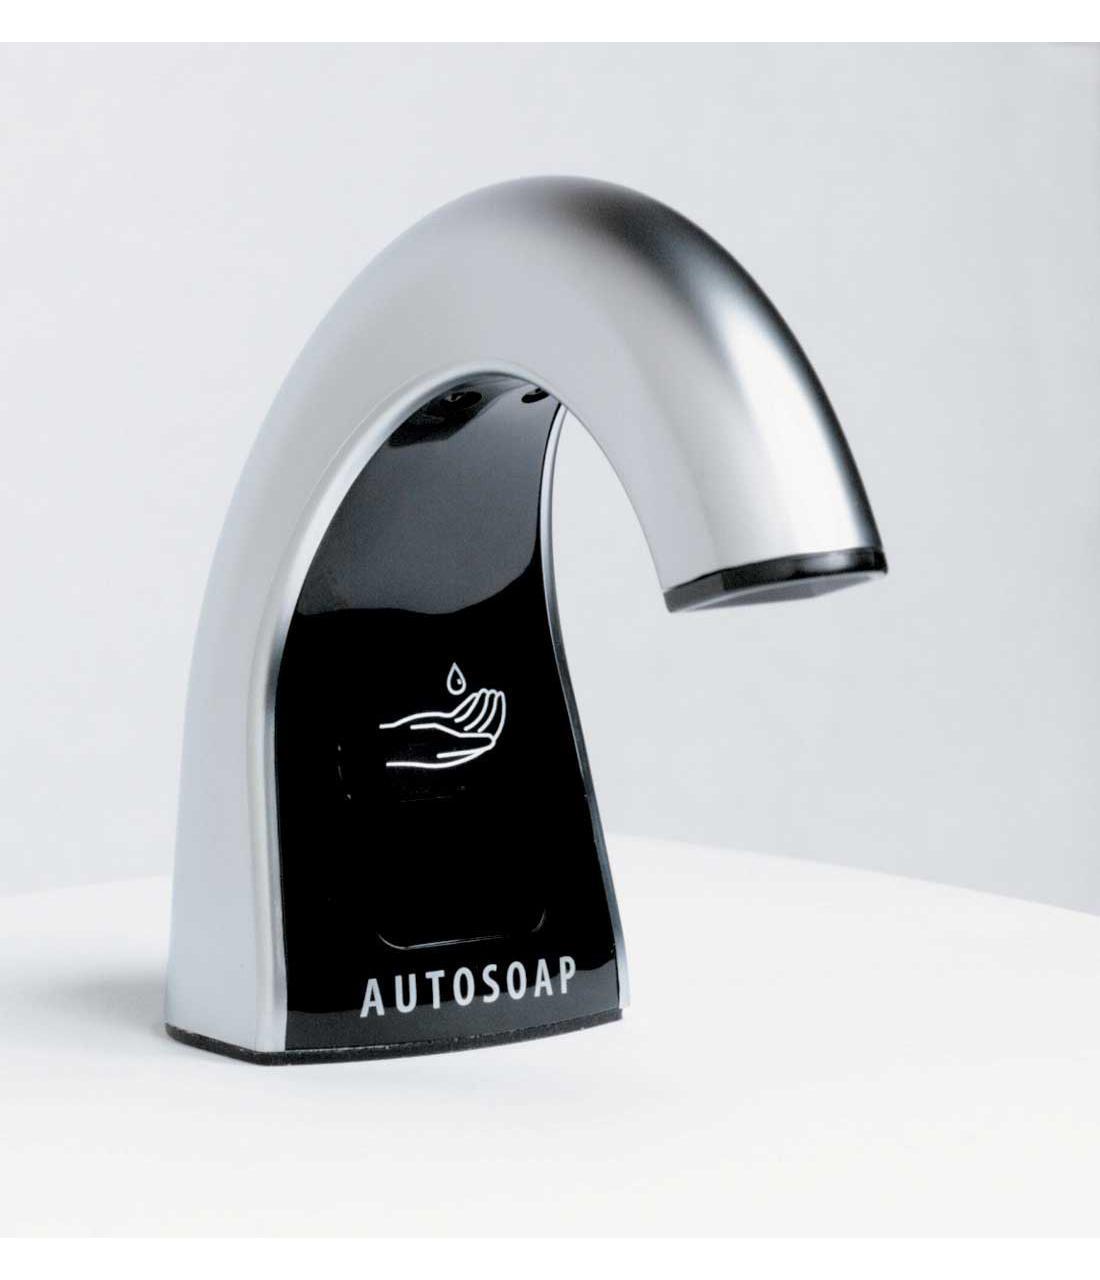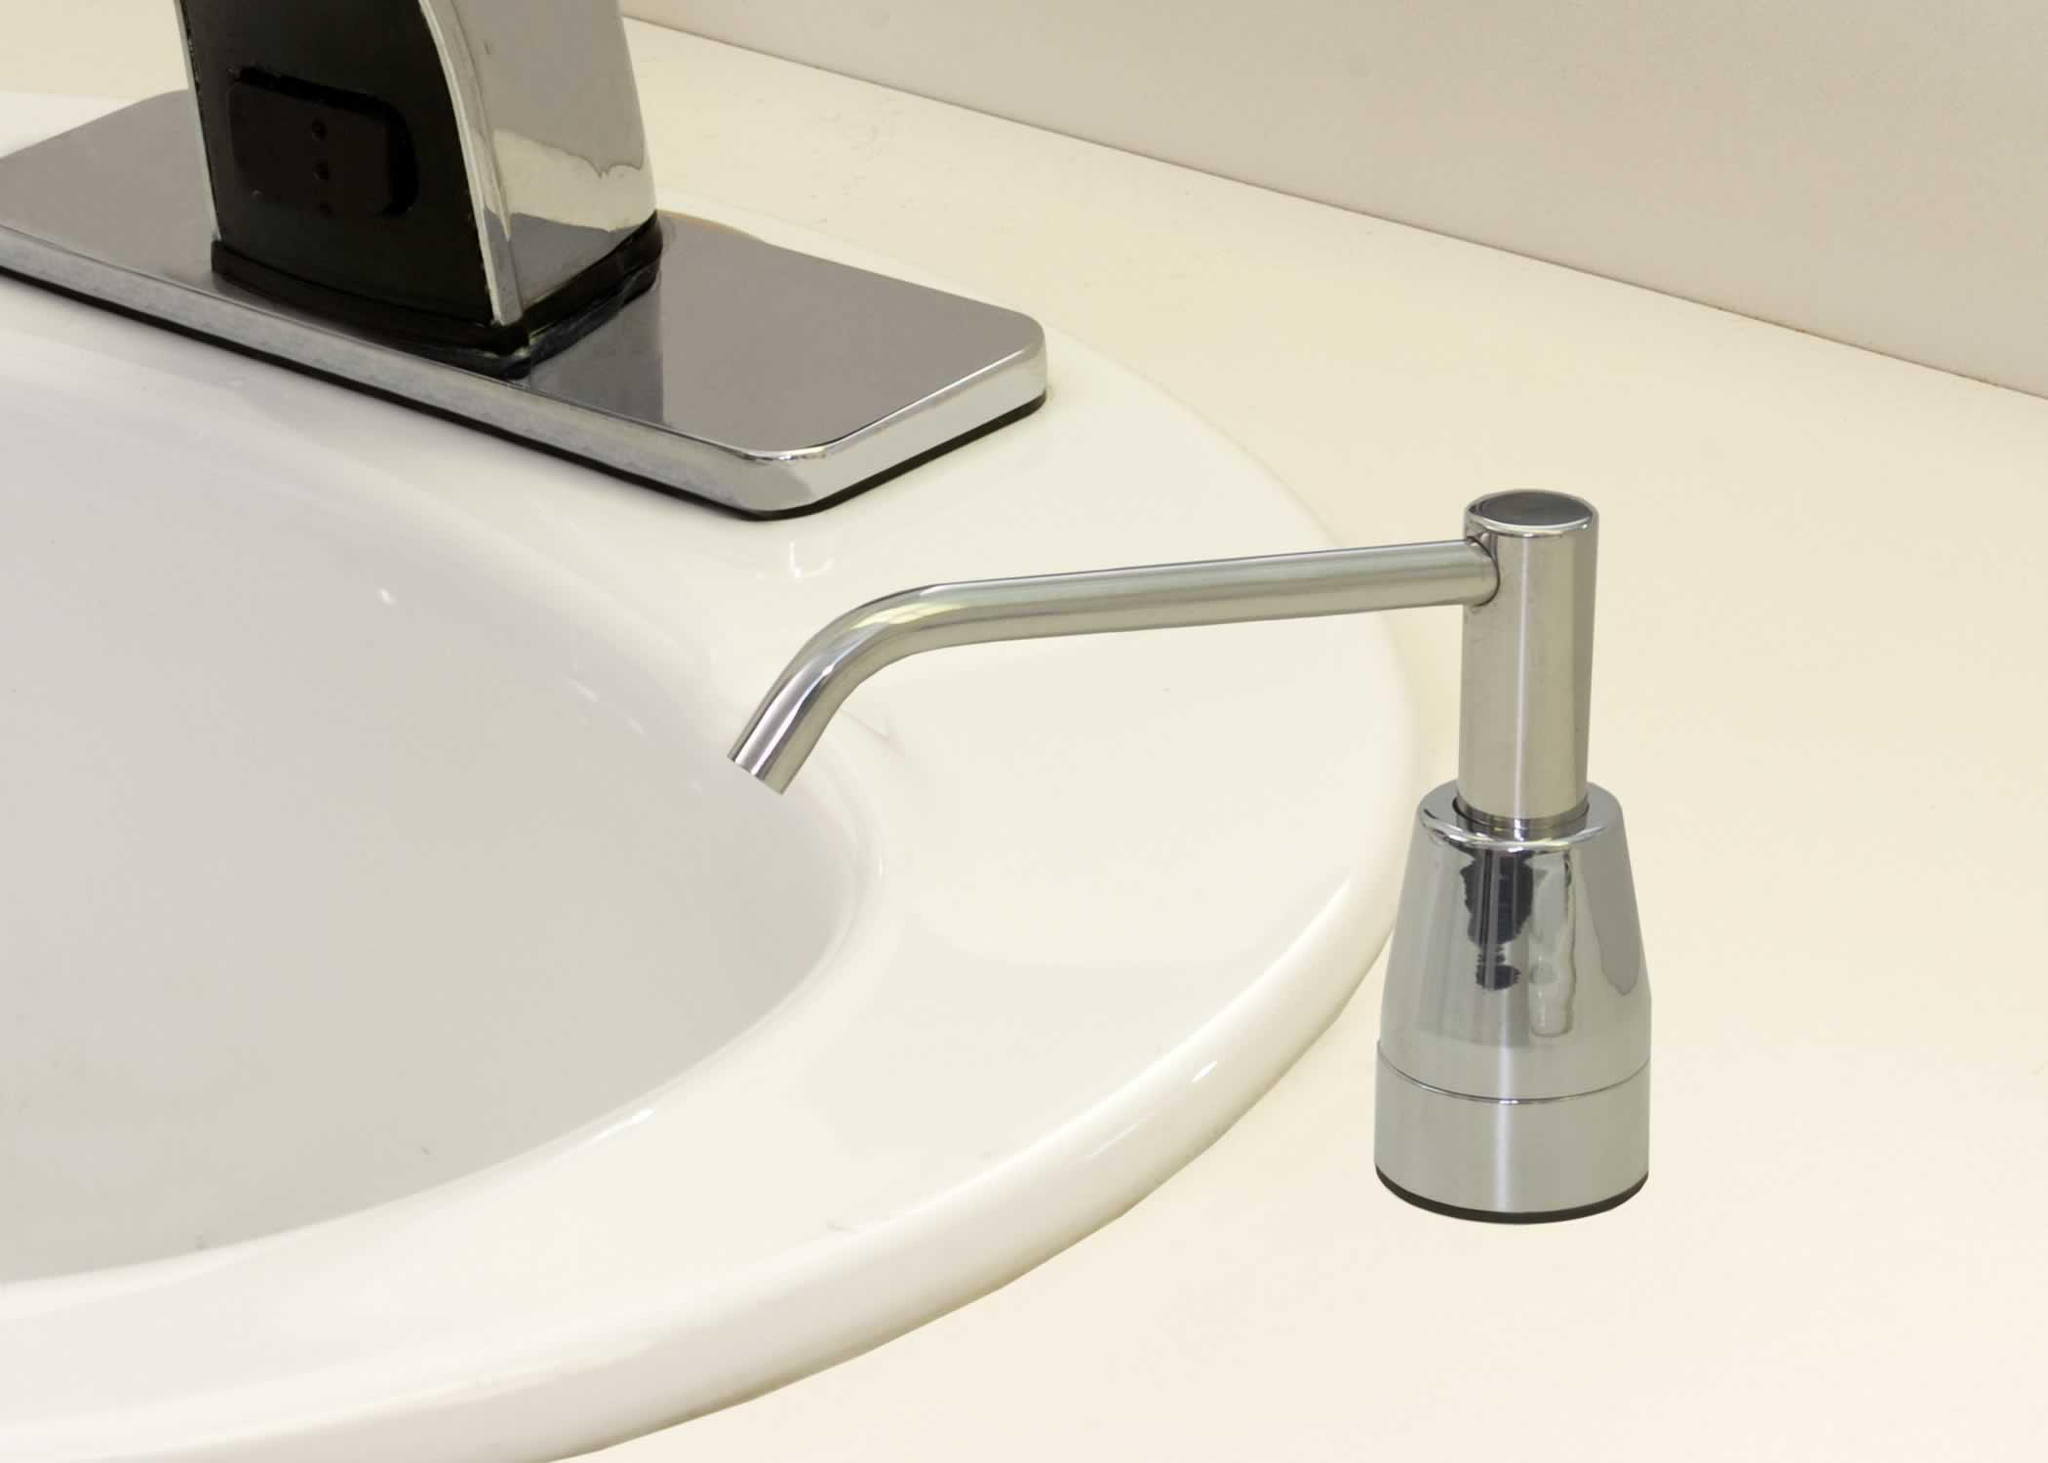The first image is the image on the left, the second image is the image on the right. Given the left and right images, does the statement "Right image includes one rounded sink with squirt-type dispenser nearby." hold true? Answer yes or no. Yes. The first image is the image on the left, the second image is the image on the right. Assess this claim about the two images: "there is exactly one curved faucet in the image on the left". Correct or not? Answer yes or no. Yes. 